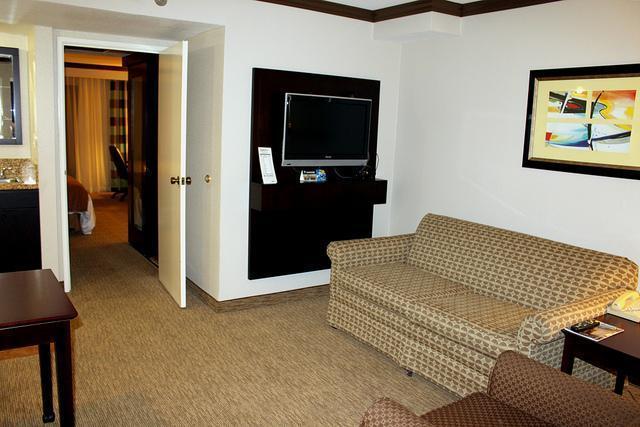How many couches can you see?
Give a very brief answer. 2. How many levels does this bus have?
Give a very brief answer. 0. 